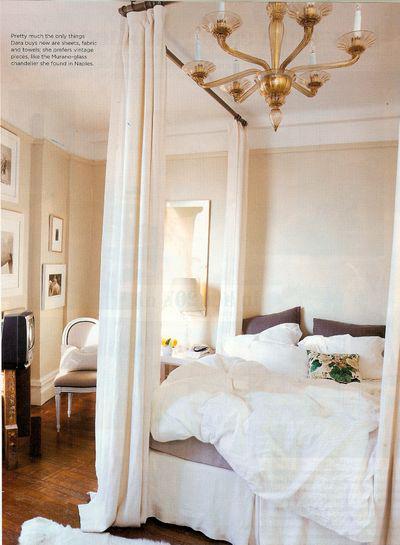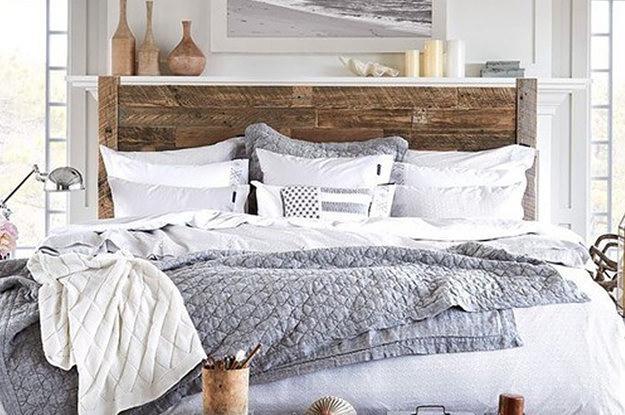The first image is the image on the left, the second image is the image on the right. Considering the images on both sides, is "There are flowers in a vase in one of the images." valid? Answer yes or no. No. 